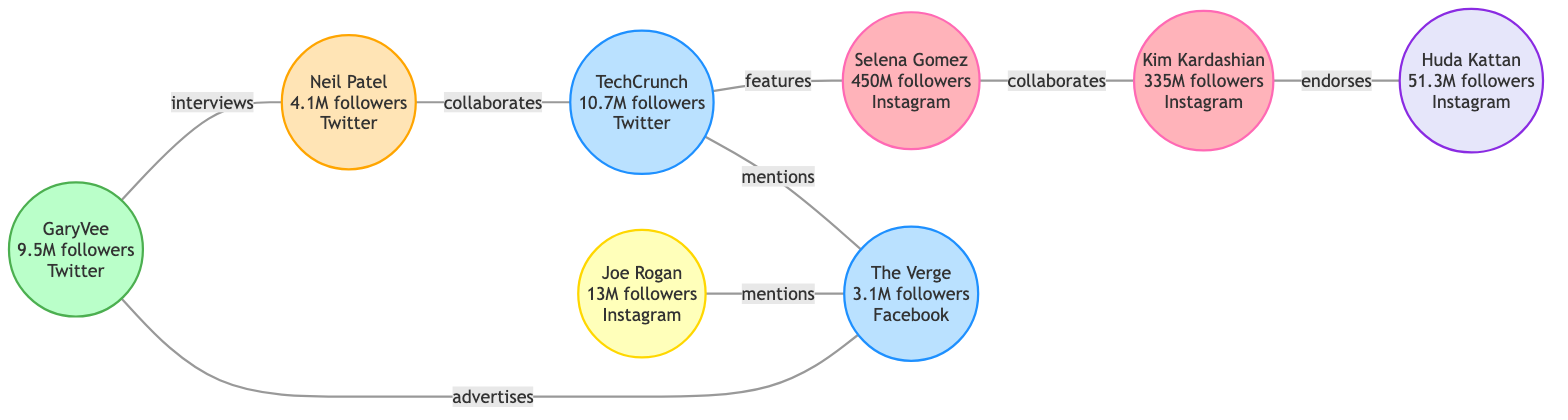What is the total number of influential profiles in the network? Counting the number of nodes listed in the diagram reveals there are eight influential profiles present, each represented as a distinct node.
Answer: 8 Who has the highest number of followers? Examining the follower counts associated with each node shows that Selena Gomez has the highest number of followers at 450 million.
Answer: Selena Gomez What platform does TechCrunch use? Looking at the node for TechCrunch reveals that it operates on Twitter, which is specified as its platform.
Answer: Twitter Which profile collaborates with Kim Kardashian? The edges indicate that Selena Gomez is linked to Kim Kardashian through a collaboration relationship.
Answer: Selena Gomez How many followers does Huda Kattan have? Directly checking the node for Huda Kattan shows that she has 51.3 million followers.
Answer: 51.3 million Which influencer is involved in advertising with GaryVee? The edges display that GaryVee advertises in connection with The Verge. This can be confirmed by tracing the edge from GaryVee to The Verge.
Answer: The Verge How many relationships does Joe Rogan have in the diagram? The examination of Joe Rogan’s connections in the edges reveals that he has two relationships: one with The Verge through mentions and one with others.
Answer: 2 Which profiles have endorsed Huda Kattan? By reviewing the edges, it becomes clear that no other profiles are endorsed by Huda Kattan, as she only has an endorsement relationship with Kim Kardashian.
Answer: Kim Kardashian What type of relationship exists between TechCrunch and Selena Gomez? The edge linking TechCrunch to Selena Gomez shows that the relationship is categorized as a features connection.
Answer: features 